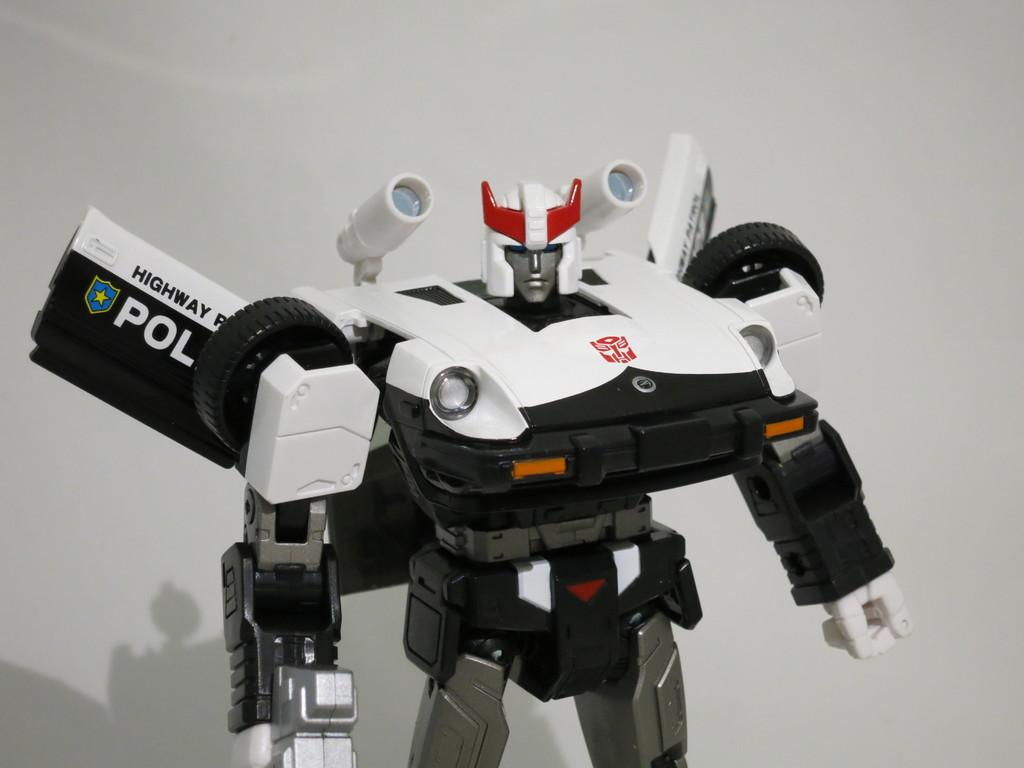<image>
Write a terse but informative summary of the picture. A black and white Highway Patrol Police transformer figure 